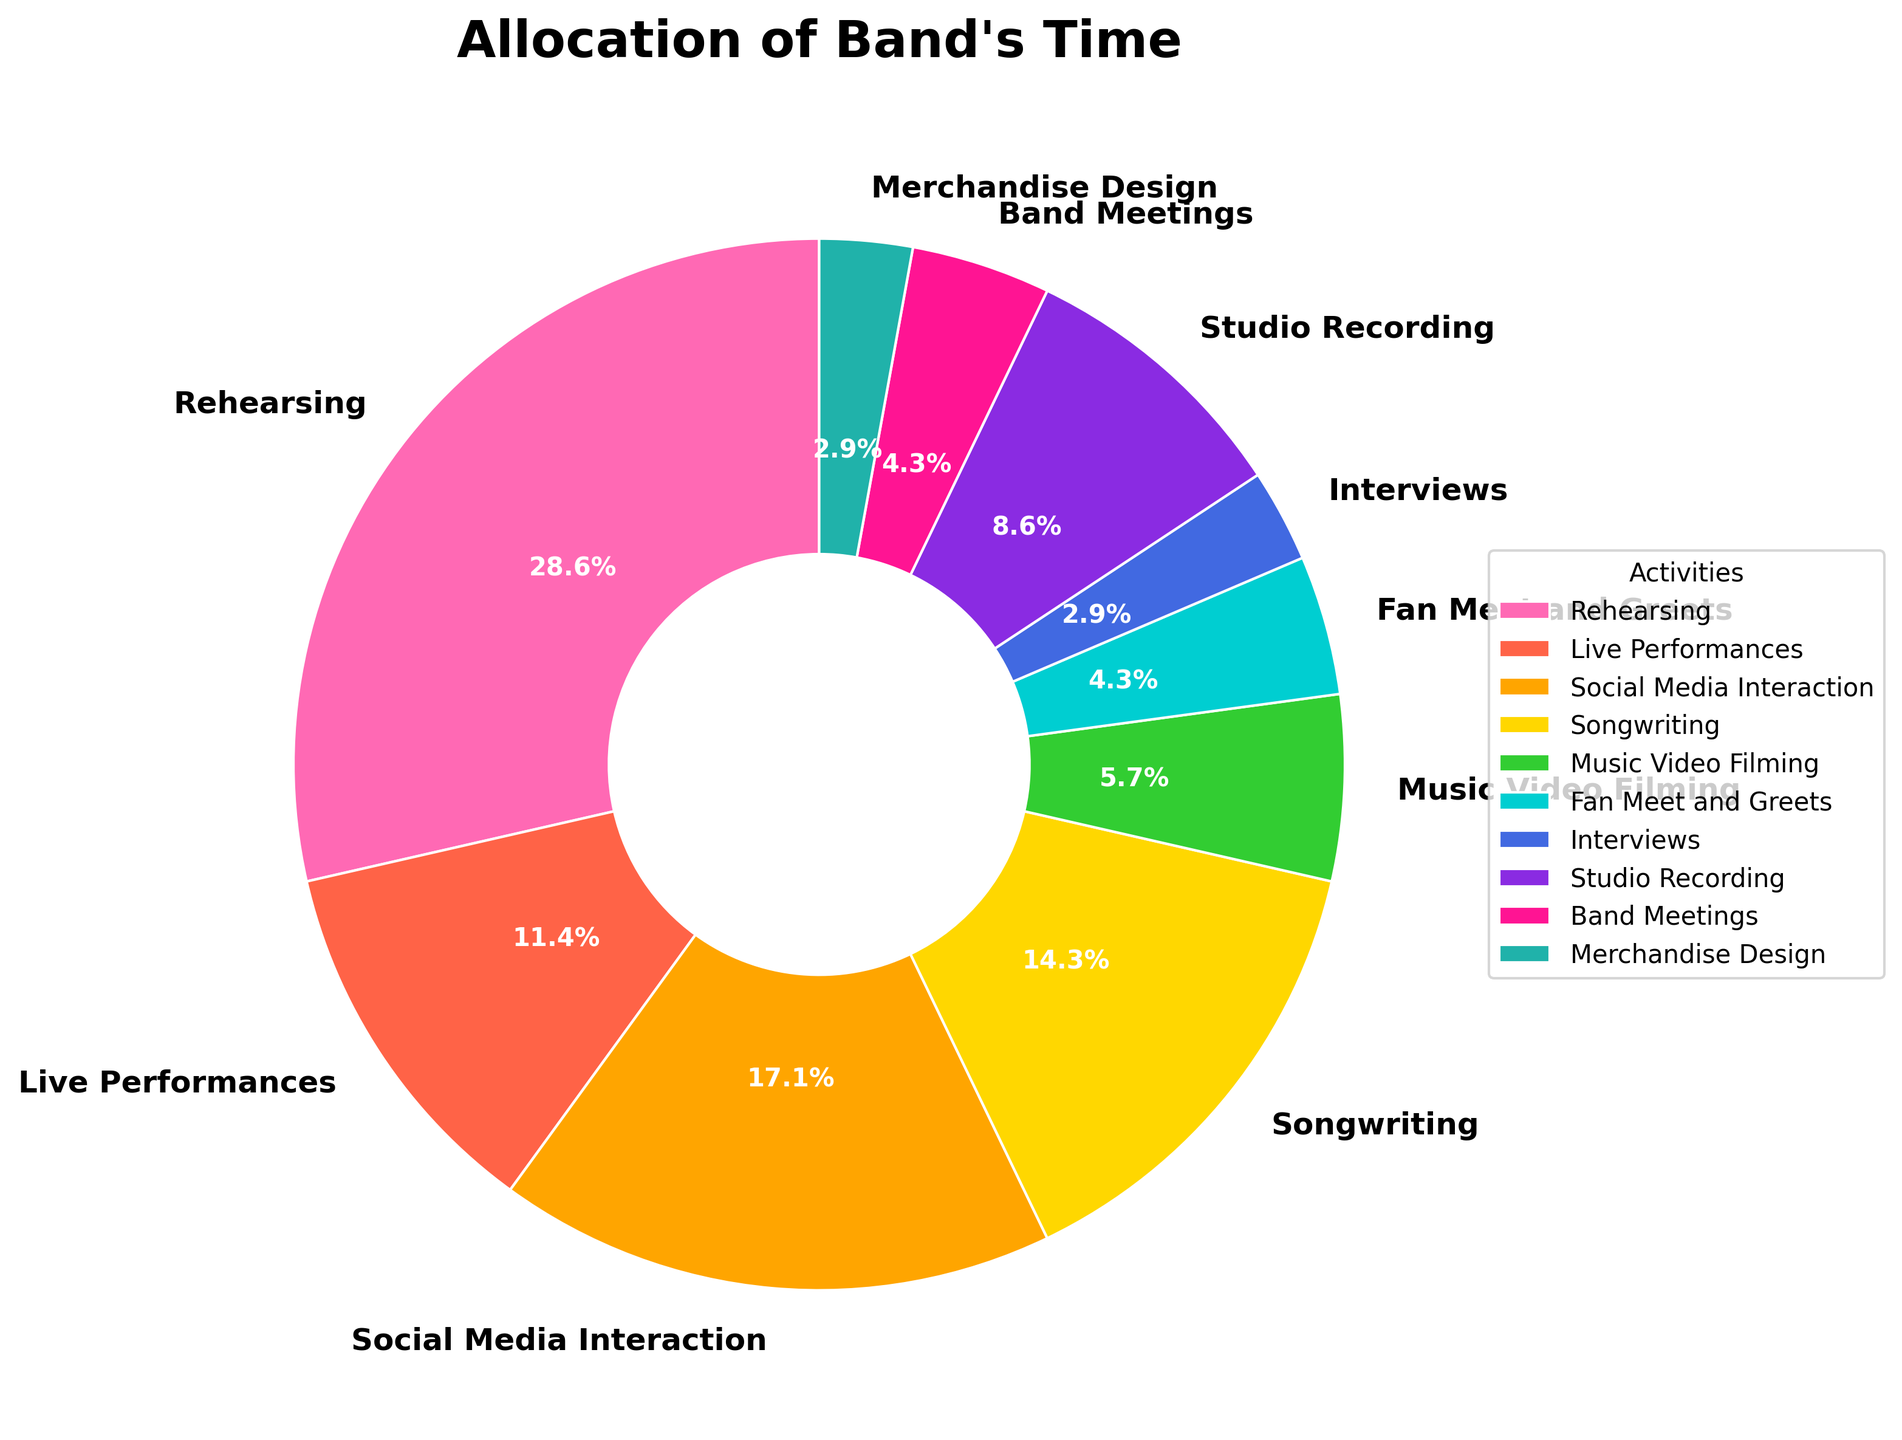What's the total amount of time spent on rehearsing and live performances each week? First, find the time spent on rehearsing (20 hours) and the time spent on live performances (8 hours). Add these two values together: 20 + 8 = 28 hours
Answer: 28 hours Which activity does the band spend the least amount of time on? Look at the pie chart and identify the segment with the smallest percentage. The smallest segment represents Interviews at 2 hours per week.
Answer: Interviews Does the band spend more time interacting with fans through social media or through fan meet and greets? Compare the hours spent on "Social Media Interaction" (12 hours) with "Fan Meet and Greets" (3 hours). Social Media Interaction involves more time, 12 hours vs. 3 hours.
Answer: Social Media Interaction What is the combined percentage of time spent on songwriting and studio recording? First, find the hours for songwriting (10 hours) and for studio recording (6 hours). Add these together: 10 + 6 = 16 hours. The total time is 70 hours. Calculate the percentage: (16/70) * 100 = ~22.9%.
Answer: ~22.9% How does the time spent on merchandise design compare to fan meet and greets and interviews? Identify the time spent on "Merchandise Design" (2 hours), "Fan Meet and Greets" (3 hours), and "Interviews" (2 hours). Merchandise Design time is equal to Interview time and less than Fan Meet and Greets.
Answer: Equal to Interviews, less than Fan Meet and Greets What is the average time spent on rehearsing, songwriting, and studio recording? First, find the time spent on each activity: Rehearsing (20 hours), Songwriting (10 hours), and Studio Recording (6 hours). Sum these up: 20 + 10 + 6 = 36 hours. Divide by the number of activities (3): 36/3 = 12 hours.
Answer: 12 hours Out of all the activities, which one occupies exactly 3 hours per week? Look at the pie chart and identify the segment labeled with 3 hours. The activities with 3 hours per week are "Fan Meet and Greets" and "Band Meetings."
Answer: Fan Meet and Greets, Band Meetings How many more hours does the band spend on rehearsing compared to music video filming? Find the hours spent on rehearsing (20 hours) and music video filming (4 hours). Subtract the time spent on music video filming from rehearsing: 20 - 4 = 16 hours.
Answer: 16 hours 